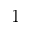Convert formula to latex. <formula><loc_0><loc_0><loc_500><loc_500>1</formula> 